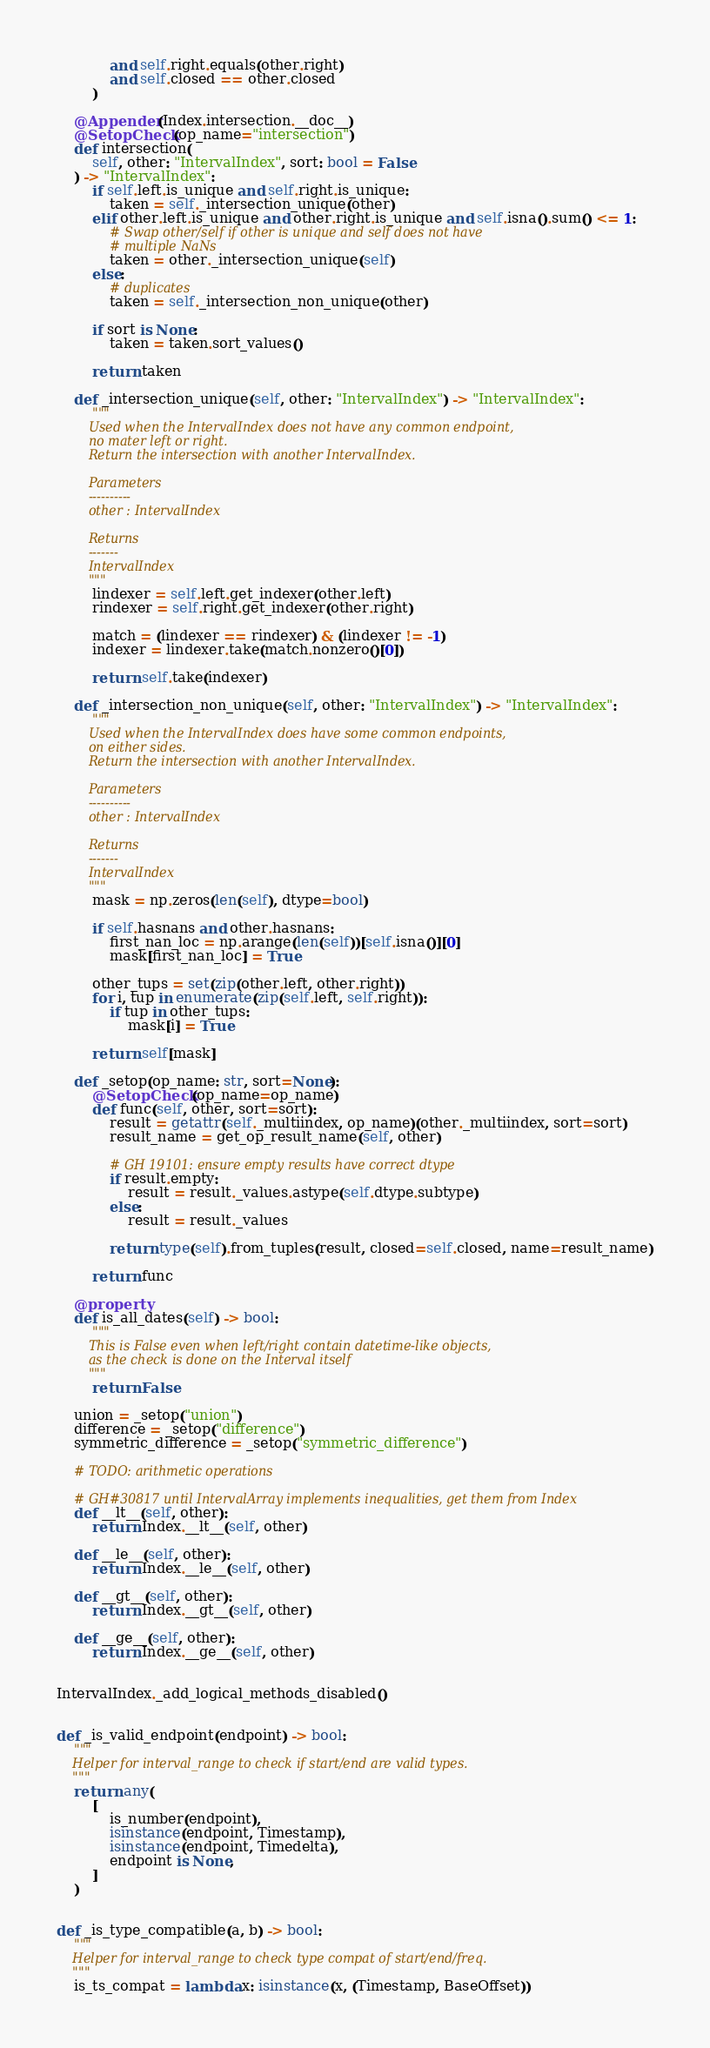Convert code to text. <code><loc_0><loc_0><loc_500><loc_500><_Python_>            and self.right.equals(other.right)
            and self.closed == other.closed
        )

    @Appender(Index.intersection.__doc__)
    @SetopCheck(op_name="intersection")
    def intersection(
        self, other: "IntervalIndex", sort: bool = False
    ) -> "IntervalIndex":
        if self.left.is_unique and self.right.is_unique:
            taken = self._intersection_unique(other)
        elif other.left.is_unique and other.right.is_unique and self.isna().sum() <= 1:
            # Swap other/self if other is unique and self does not have
            # multiple NaNs
            taken = other._intersection_unique(self)
        else:
            # duplicates
            taken = self._intersection_non_unique(other)

        if sort is None:
            taken = taken.sort_values()

        return taken

    def _intersection_unique(self, other: "IntervalIndex") -> "IntervalIndex":
        """
        Used when the IntervalIndex does not have any common endpoint,
        no mater left or right.
        Return the intersection with another IntervalIndex.

        Parameters
        ----------
        other : IntervalIndex

        Returns
        -------
        IntervalIndex
        """
        lindexer = self.left.get_indexer(other.left)
        rindexer = self.right.get_indexer(other.right)

        match = (lindexer == rindexer) & (lindexer != -1)
        indexer = lindexer.take(match.nonzero()[0])

        return self.take(indexer)

    def _intersection_non_unique(self, other: "IntervalIndex") -> "IntervalIndex":
        """
        Used when the IntervalIndex does have some common endpoints,
        on either sides.
        Return the intersection with another IntervalIndex.

        Parameters
        ----------
        other : IntervalIndex

        Returns
        -------
        IntervalIndex
        """
        mask = np.zeros(len(self), dtype=bool)

        if self.hasnans and other.hasnans:
            first_nan_loc = np.arange(len(self))[self.isna()][0]
            mask[first_nan_loc] = True

        other_tups = set(zip(other.left, other.right))
        for i, tup in enumerate(zip(self.left, self.right)):
            if tup in other_tups:
                mask[i] = True

        return self[mask]

    def _setop(op_name: str, sort=None):
        @SetopCheck(op_name=op_name)
        def func(self, other, sort=sort):
            result = getattr(self._multiindex, op_name)(other._multiindex, sort=sort)
            result_name = get_op_result_name(self, other)

            # GH 19101: ensure empty results have correct dtype
            if result.empty:
                result = result._values.astype(self.dtype.subtype)
            else:
                result = result._values

            return type(self).from_tuples(result, closed=self.closed, name=result_name)

        return func

    @property
    def is_all_dates(self) -> bool:
        """
        This is False even when left/right contain datetime-like objects,
        as the check is done on the Interval itself
        """
        return False

    union = _setop("union")
    difference = _setop("difference")
    symmetric_difference = _setop("symmetric_difference")

    # TODO: arithmetic operations

    # GH#30817 until IntervalArray implements inequalities, get them from Index
    def __lt__(self, other):
        return Index.__lt__(self, other)

    def __le__(self, other):
        return Index.__le__(self, other)

    def __gt__(self, other):
        return Index.__gt__(self, other)

    def __ge__(self, other):
        return Index.__ge__(self, other)


IntervalIndex._add_logical_methods_disabled()


def _is_valid_endpoint(endpoint) -> bool:
    """
    Helper for interval_range to check if start/end are valid types.
    """
    return any(
        [
            is_number(endpoint),
            isinstance(endpoint, Timestamp),
            isinstance(endpoint, Timedelta),
            endpoint is None,
        ]
    )


def _is_type_compatible(a, b) -> bool:
    """
    Helper for interval_range to check type compat of start/end/freq.
    """
    is_ts_compat = lambda x: isinstance(x, (Timestamp, BaseOffset))</code> 